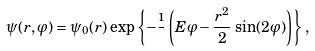Convert formula to latex. <formula><loc_0><loc_0><loc_500><loc_500>\psi ( r , \varphi ) = \psi _ { 0 } ( r ) \, \exp \left \{ - \frac { \i } { } \left ( E \varphi - \frac { r ^ { 2 } } { 2 } \, \sin ( 2 \varphi ) \right ) \right \} \, ,</formula> 